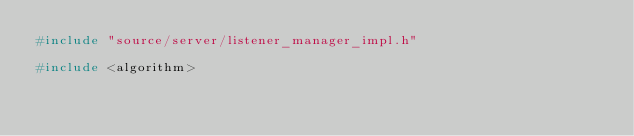Convert code to text. <code><loc_0><loc_0><loc_500><loc_500><_C++_>#include "source/server/listener_manager_impl.h"

#include <algorithm>
</code> 